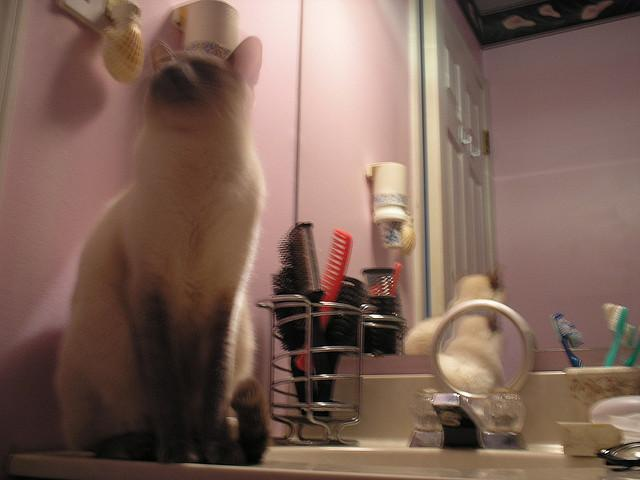What is the red item inside the holder? comb 